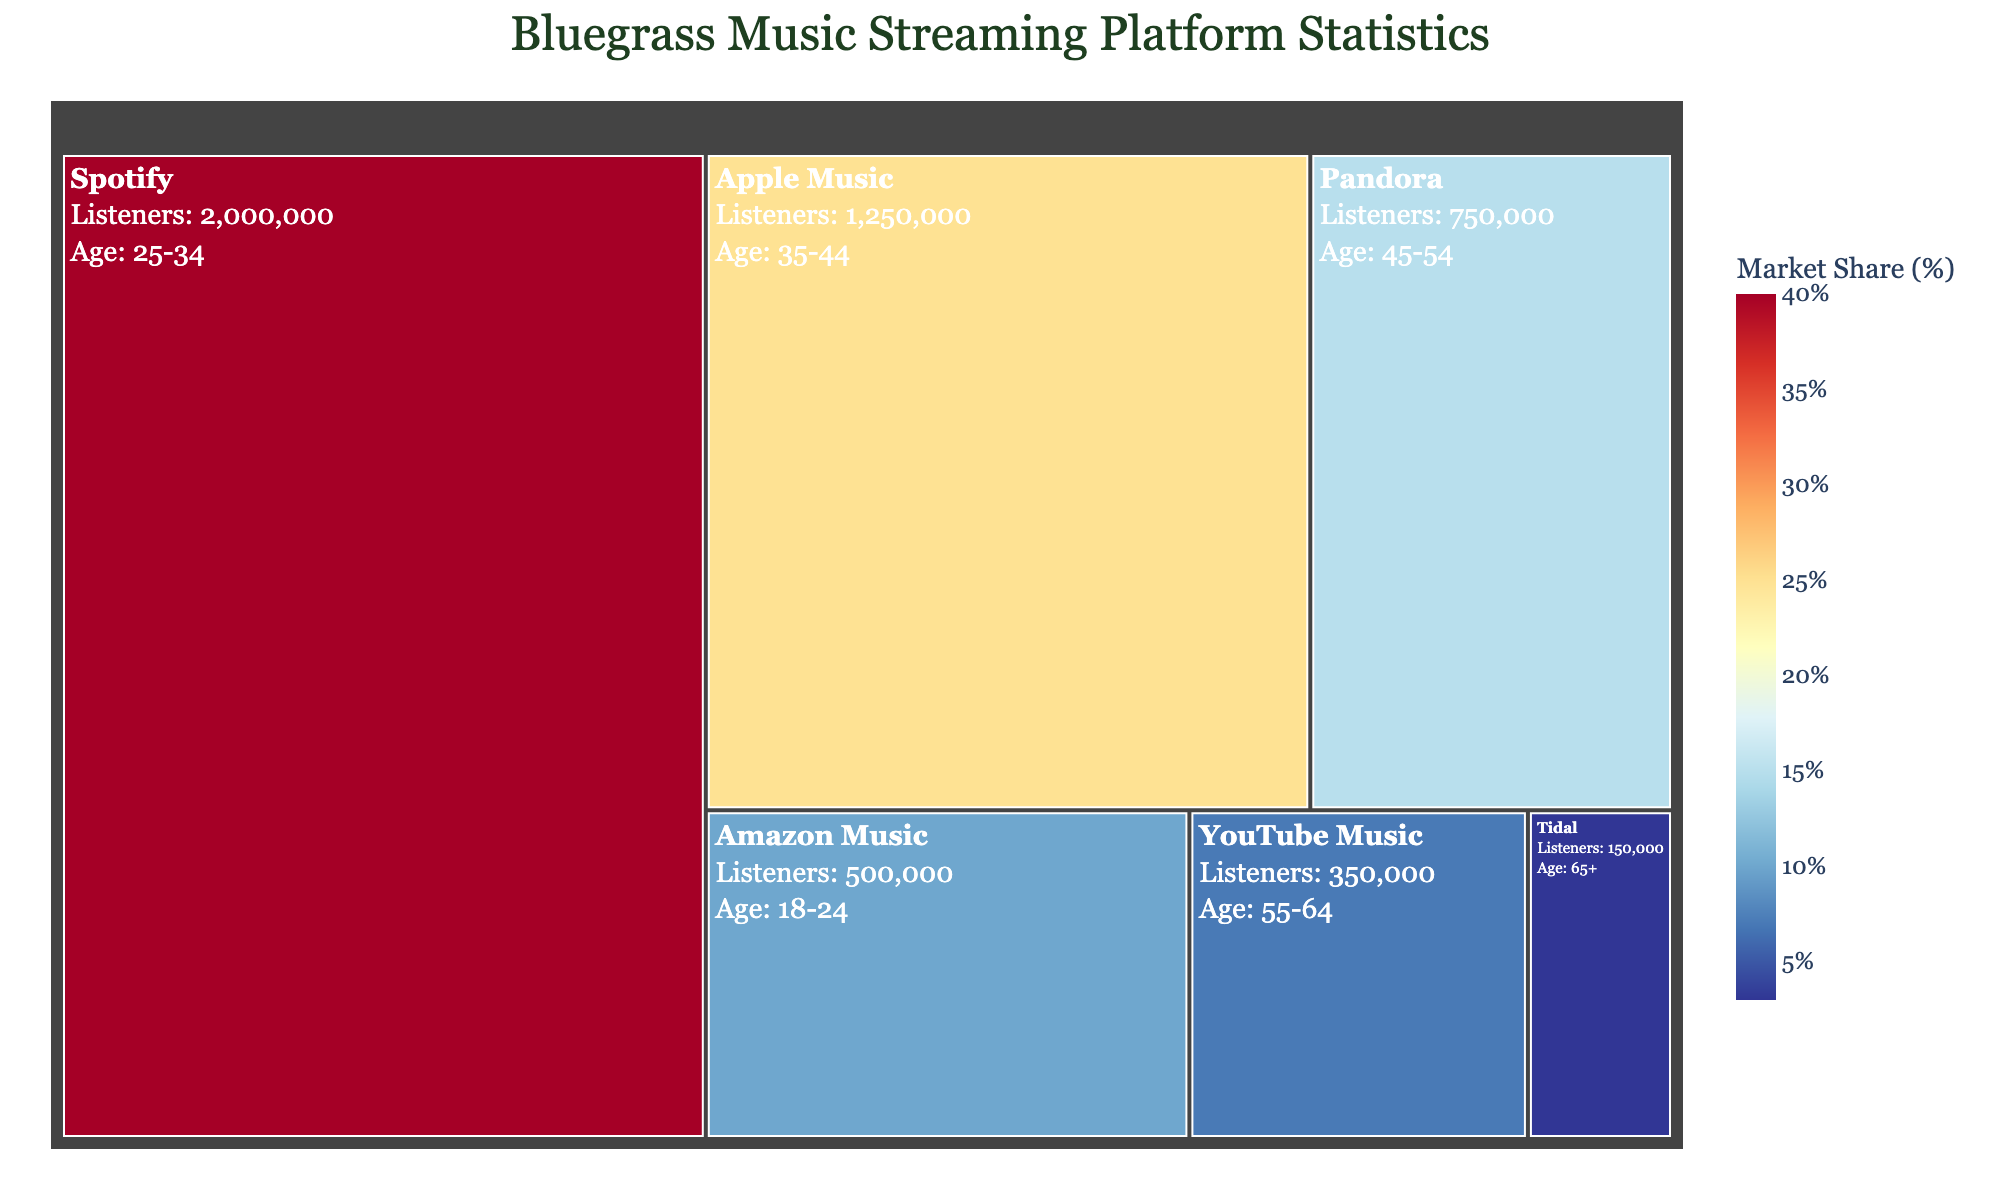What is the title of the figure? The title of the figure can be found at the top. It reads "Bluegrass Music Streaming Platform Statistics."
Answer: Bluegrass Music Streaming Platform Statistics What is the largest market share depicted in the figure? By looking at the color intensity and the size of the section, we see that Spotify has the largest market share. The hover data confirms it shows Spotify with 40%.
Answer: 40% How many listeners does Amazon Music have for bluegrass music? Referring to the text in the Amazon Music section, it shows 500,000 listeners.
Answer: 500,000 Which platform has the smallest market share? By locating the smallest section in the treemap, we find Tidal. The hover data further verifies Tidal has 3%.
Answer: Tidal What age group is the most prominent for YouTube Music listeners? Hovering over or reading the text within the YouTube Music section, it shows that the age group is 55-64.
Answer: 55-64 Which platform has twice the market share of Amazon Music? Amazon Music has a 10% market share, so a platform with twice that would have 20%. Neither of the platforms match exactly twice, but Apple Music with 25% is the closest higher value.
Answer: Apple Music If the total number of listeners is combined across all platforms, what is the sum? Sum up all the listeners from the treemap: 2,000,000 (Spotify) + 1,250,000 (Apple Music) + 750,000 (Pandora) + 500,000 (Amazon Music) + 350,000 (YouTube Music) + 150,000 (Tidal) = 5,000,000 listeners.
Answer: 5,000,000 How does the median age group of listeners differ between Apple Music and Pandora? Apple Music's age group is 35-44, while Pandora's is 45-54. This means the listeners of Pandora are generally older.
Answer: Pandora's listeners are older What is the most likely reason for YouTube Music having fewer listeners compared to Apple Music? By comparing both the market share and number of listeners, it becomes apparent that Apple Music has a more significant market share (25%) compared to YouTube Music's 7%. Larger market share typically leads to more listeners.
Answer: Larger market share of Apple Music Among the listed platforms, which one likely contributes the least to the overall market share and why? By examining the sections of the treemap and their respective market shares, Tidal, with a 3% share, contributes the least due to its smallest segment.
Answer: Tidal, smallest market share 